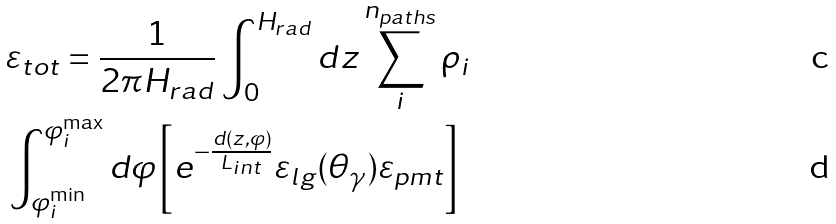Convert formula to latex. <formula><loc_0><loc_0><loc_500><loc_500>& \varepsilon _ { t o t } = \frac { 1 } { 2 \pi H _ { r a d } } \int _ { 0 } ^ { H _ { r a d } } d z \sum _ { i } ^ { n _ { p a t h s } } \rho _ { i } \\ & \int _ { \varphi ^ { \min } _ { i } } ^ { \varphi ^ { \max } _ { i } } d \varphi \left [ e ^ { - \frac { d ( z , \varphi ) } { L _ { i n t } } } \varepsilon _ { l g } ( \theta _ { \gamma } ) \varepsilon _ { p m t } \right ]</formula> 